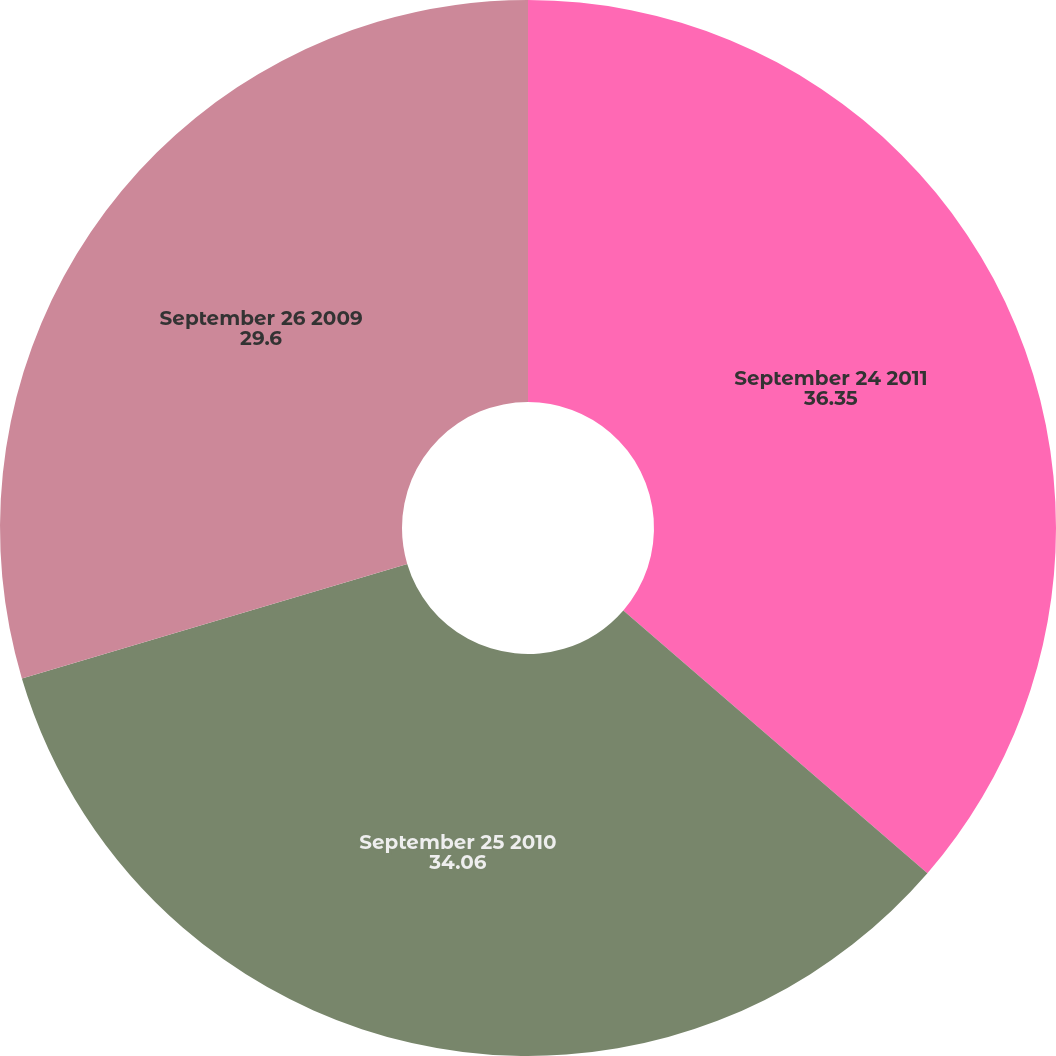<chart> <loc_0><loc_0><loc_500><loc_500><pie_chart><fcel>September 24 2011<fcel>September 25 2010<fcel>September 26 2009<nl><fcel>36.35%<fcel>34.06%<fcel>29.6%<nl></chart> 